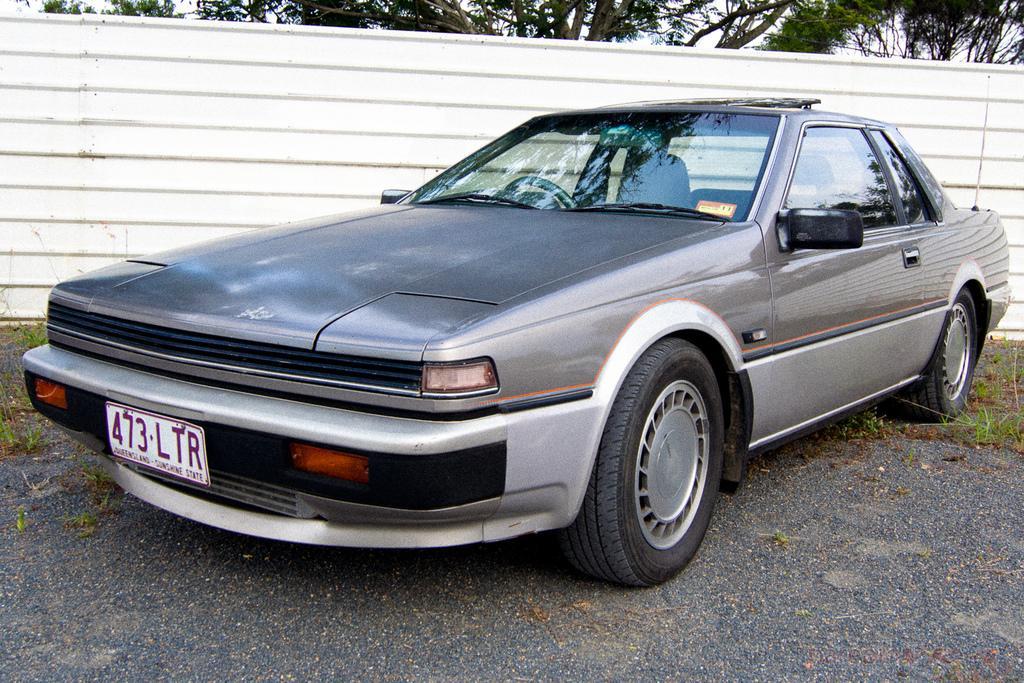Could you give a brief overview of what you see in this image? In this image there is a car on the road, grass , compound wall , and in the background there are trees and sky. 